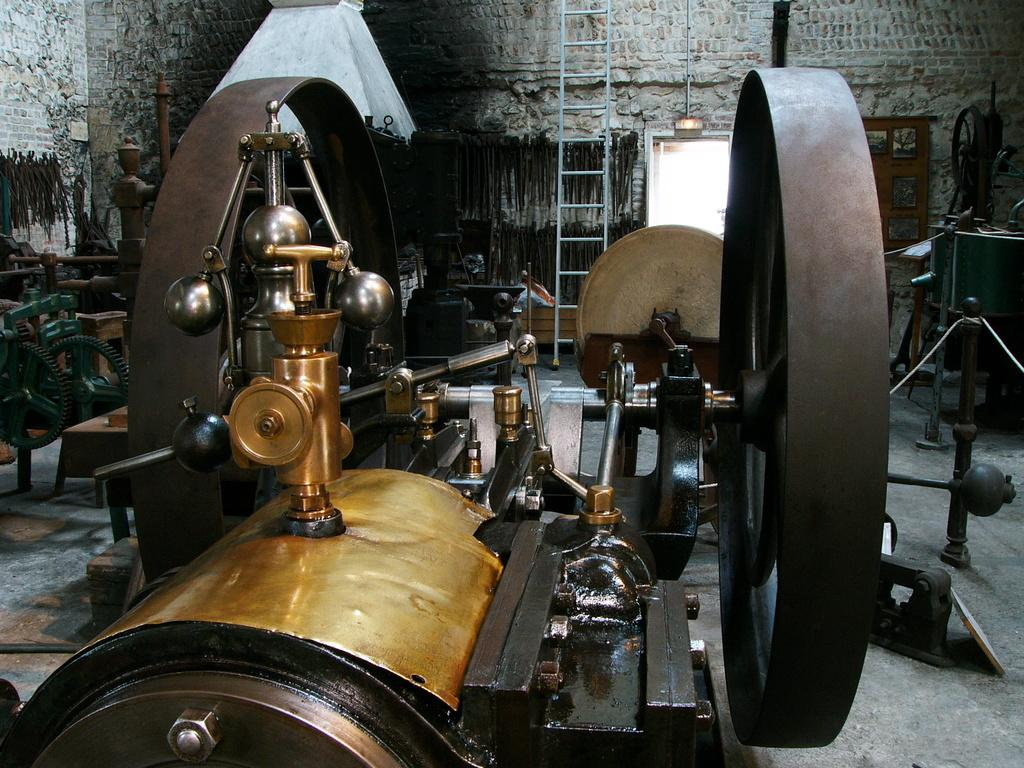What type of objects can be seen on the floor in the image? There are machines on the floor in the image. What is the purpose of the ladder in the image? The ladder is near a wall, which suggests it might be used for reaching higher areas. What feature of the wall is mentioned in the image? The wall has a door. What type of tooth is visible in the image? There is no tooth present in the image. What industry is represented by the machines in the image? The image does not specify the industry associated with the machines. 